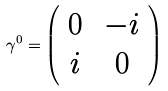<formula> <loc_0><loc_0><loc_500><loc_500>\gamma ^ { 0 } = \left ( \begin{array} { c c } 0 & \, - i \\ i & \, 0 \end{array} \right )</formula> 